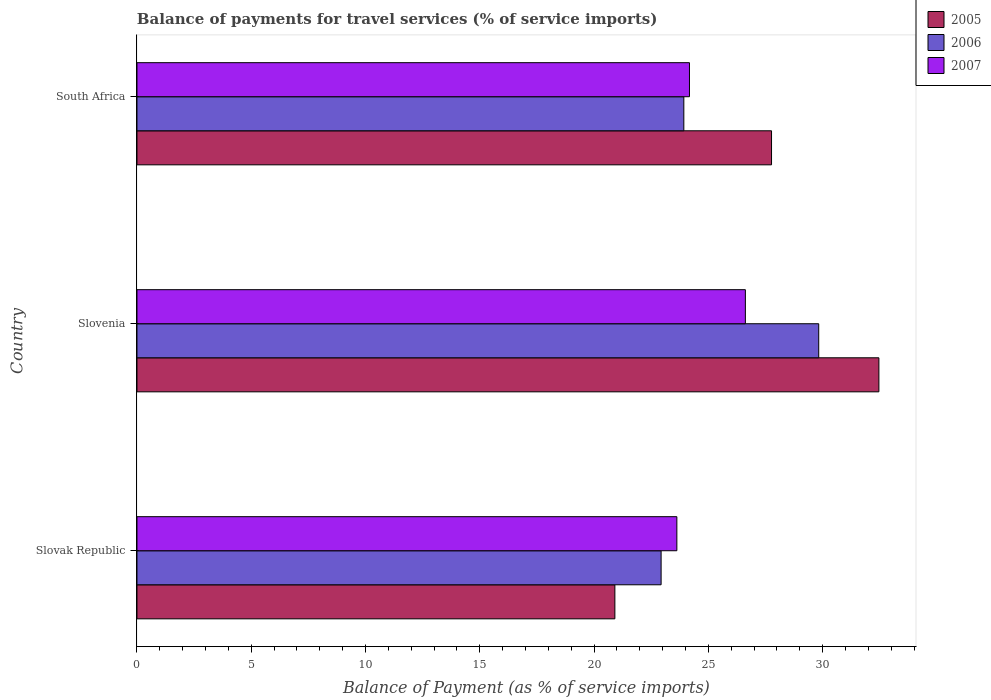How many different coloured bars are there?
Make the answer very short. 3. How many groups of bars are there?
Offer a terse response. 3. Are the number of bars per tick equal to the number of legend labels?
Offer a terse response. Yes. Are the number of bars on each tick of the Y-axis equal?
Your response must be concise. Yes. How many bars are there on the 1st tick from the bottom?
Provide a succinct answer. 3. What is the label of the 1st group of bars from the top?
Give a very brief answer. South Africa. What is the balance of payments for travel services in 2005 in Slovenia?
Offer a terse response. 32.46. Across all countries, what is the maximum balance of payments for travel services in 2006?
Offer a very short reply. 29.83. Across all countries, what is the minimum balance of payments for travel services in 2006?
Make the answer very short. 22.93. In which country was the balance of payments for travel services in 2005 maximum?
Give a very brief answer. Slovenia. In which country was the balance of payments for travel services in 2007 minimum?
Offer a terse response. Slovak Republic. What is the total balance of payments for travel services in 2007 in the graph?
Give a very brief answer. 74.41. What is the difference between the balance of payments for travel services in 2006 in Slovenia and that in South Africa?
Provide a succinct answer. 5.9. What is the difference between the balance of payments for travel services in 2006 in Slovak Republic and the balance of payments for travel services in 2007 in South Africa?
Provide a short and direct response. -1.24. What is the average balance of payments for travel services in 2006 per country?
Make the answer very short. 25.56. What is the difference between the balance of payments for travel services in 2007 and balance of payments for travel services in 2005 in South Africa?
Your answer should be very brief. -3.59. In how many countries, is the balance of payments for travel services in 2005 greater than 33 %?
Your answer should be compact. 0. What is the ratio of the balance of payments for travel services in 2005 in Slovak Republic to that in South Africa?
Your answer should be compact. 0.75. What is the difference between the highest and the second highest balance of payments for travel services in 2006?
Your response must be concise. 5.9. What is the difference between the highest and the lowest balance of payments for travel services in 2005?
Make the answer very short. 11.55. In how many countries, is the balance of payments for travel services in 2007 greater than the average balance of payments for travel services in 2007 taken over all countries?
Offer a very short reply. 1. Is the sum of the balance of payments for travel services in 2006 in Slovak Republic and South Africa greater than the maximum balance of payments for travel services in 2005 across all countries?
Give a very brief answer. Yes. What does the 3rd bar from the bottom in Slovak Republic represents?
Provide a succinct answer. 2007. Is it the case that in every country, the sum of the balance of payments for travel services in 2005 and balance of payments for travel services in 2006 is greater than the balance of payments for travel services in 2007?
Your answer should be compact. Yes. How many bars are there?
Give a very brief answer. 9. What is the difference between two consecutive major ticks on the X-axis?
Offer a very short reply. 5. Are the values on the major ticks of X-axis written in scientific E-notation?
Your response must be concise. No. Does the graph contain grids?
Give a very brief answer. No. Where does the legend appear in the graph?
Offer a terse response. Top right. How many legend labels are there?
Your answer should be very brief. 3. How are the legend labels stacked?
Give a very brief answer. Vertical. What is the title of the graph?
Give a very brief answer. Balance of payments for travel services (% of service imports). Does "1977" appear as one of the legend labels in the graph?
Offer a very short reply. No. What is the label or title of the X-axis?
Ensure brevity in your answer.  Balance of Payment (as % of service imports). What is the label or title of the Y-axis?
Provide a succinct answer. Country. What is the Balance of Payment (as % of service imports) of 2005 in Slovak Republic?
Ensure brevity in your answer.  20.91. What is the Balance of Payment (as % of service imports) of 2006 in Slovak Republic?
Ensure brevity in your answer.  22.93. What is the Balance of Payment (as % of service imports) in 2007 in Slovak Republic?
Your answer should be very brief. 23.62. What is the Balance of Payment (as % of service imports) of 2005 in Slovenia?
Give a very brief answer. 32.46. What is the Balance of Payment (as % of service imports) of 2006 in Slovenia?
Provide a short and direct response. 29.83. What is the Balance of Payment (as % of service imports) in 2007 in Slovenia?
Offer a very short reply. 26.62. What is the Balance of Payment (as % of service imports) in 2005 in South Africa?
Make the answer very short. 27.76. What is the Balance of Payment (as % of service imports) in 2006 in South Africa?
Keep it short and to the point. 23.93. What is the Balance of Payment (as % of service imports) in 2007 in South Africa?
Ensure brevity in your answer.  24.17. Across all countries, what is the maximum Balance of Payment (as % of service imports) in 2005?
Offer a very short reply. 32.46. Across all countries, what is the maximum Balance of Payment (as % of service imports) in 2006?
Make the answer very short. 29.83. Across all countries, what is the maximum Balance of Payment (as % of service imports) in 2007?
Offer a terse response. 26.62. Across all countries, what is the minimum Balance of Payment (as % of service imports) in 2005?
Offer a terse response. 20.91. Across all countries, what is the minimum Balance of Payment (as % of service imports) of 2006?
Offer a terse response. 22.93. Across all countries, what is the minimum Balance of Payment (as % of service imports) in 2007?
Ensure brevity in your answer.  23.62. What is the total Balance of Payment (as % of service imports) of 2005 in the graph?
Your response must be concise. 81.13. What is the total Balance of Payment (as % of service imports) in 2006 in the graph?
Offer a very short reply. 76.69. What is the total Balance of Payment (as % of service imports) of 2007 in the graph?
Provide a succinct answer. 74.41. What is the difference between the Balance of Payment (as % of service imports) of 2005 in Slovak Republic and that in Slovenia?
Offer a terse response. -11.55. What is the difference between the Balance of Payment (as % of service imports) in 2006 in Slovak Republic and that in Slovenia?
Offer a terse response. -6.9. What is the difference between the Balance of Payment (as % of service imports) of 2007 in Slovak Republic and that in Slovenia?
Keep it short and to the point. -3. What is the difference between the Balance of Payment (as % of service imports) in 2005 in Slovak Republic and that in South Africa?
Offer a terse response. -6.85. What is the difference between the Balance of Payment (as % of service imports) of 2006 in Slovak Republic and that in South Africa?
Your answer should be very brief. -0.99. What is the difference between the Balance of Payment (as % of service imports) of 2007 in Slovak Republic and that in South Africa?
Provide a short and direct response. -0.55. What is the difference between the Balance of Payment (as % of service imports) in 2005 in Slovenia and that in South Africa?
Ensure brevity in your answer.  4.7. What is the difference between the Balance of Payment (as % of service imports) in 2006 in Slovenia and that in South Africa?
Provide a succinct answer. 5.9. What is the difference between the Balance of Payment (as % of service imports) of 2007 in Slovenia and that in South Africa?
Give a very brief answer. 2.45. What is the difference between the Balance of Payment (as % of service imports) in 2005 in Slovak Republic and the Balance of Payment (as % of service imports) in 2006 in Slovenia?
Keep it short and to the point. -8.92. What is the difference between the Balance of Payment (as % of service imports) of 2005 in Slovak Republic and the Balance of Payment (as % of service imports) of 2007 in Slovenia?
Your answer should be compact. -5.71. What is the difference between the Balance of Payment (as % of service imports) in 2006 in Slovak Republic and the Balance of Payment (as % of service imports) in 2007 in Slovenia?
Provide a succinct answer. -3.69. What is the difference between the Balance of Payment (as % of service imports) of 2005 in Slovak Republic and the Balance of Payment (as % of service imports) of 2006 in South Africa?
Offer a very short reply. -3.02. What is the difference between the Balance of Payment (as % of service imports) of 2005 in Slovak Republic and the Balance of Payment (as % of service imports) of 2007 in South Africa?
Ensure brevity in your answer.  -3.26. What is the difference between the Balance of Payment (as % of service imports) of 2006 in Slovak Republic and the Balance of Payment (as % of service imports) of 2007 in South Africa?
Your answer should be very brief. -1.24. What is the difference between the Balance of Payment (as % of service imports) of 2005 in Slovenia and the Balance of Payment (as % of service imports) of 2006 in South Africa?
Give a very brief answer. 8.53. What is the difference between the Balance of Payment (as % of service imports) in 2005 in Slovenia and the Balance of Payment (as % of service imports) in 2007 in South Africa?
Provide a short and direct response. 8.29. What is the difference between the Balance of Payment (as % of service imports) of 2006 in Slovenia and the Balance of Payment (as % of service imports) of 2007 in South Africa?
Provide a succinct answer. 5.66. What is the average Balance of Payment (as % of service imports) in 2005 per country?
Offer a terse response. 27.04. What is the average Balance of Payment (as % of service imports) of 2006 per country?
Provide a short and direct response. 25.56. What is the average Balance of Payment (as % of service imports) of 2007 per country?
Offer a very short reply. 24.8. What is the difference between the Balance of Payment (as % of service imports) of 2005 and Balance of Payment (as % of service imports) of 2006 in Slovak Republic?
Provide a short and direct response. -2.02. What is the difference between the Balance of Payment (as % of service imports) in 2005 and Balance of Payment (as % of service imports) in 2007 in Slovak Republic?
Keep it short and to the point. -2.71. What is the difference between the Balance of Payment (as % of service imports) of 2006 and Balance of Payment (as % of service imports) of 2007 in Slovak Republic?
Your response must be concise. -0.69. What is the difference between the Balance of Payment (as % of service imports) of 2005 and Balance of Payment (as % of service imports) of 2006 in Slovenia?
Keep it short and to the point. 2.63. What is the difference between the Balance of Payment (as % of service imports) in 2005 and Balance of Payment (as % of service imports) in 2007 in Slovenia?
Your answer should be compact. 5.84. What is the difference between the Balance of Payment (as % of service imports) in 2006 and Balance of Payment (as % of service imports) in 2007 in Slovenia?
Your answer should be compact. 3.21. What is the difference between the Balance of Payment (as % of service imports) of 2005 and Balance of Payment (as % of service imports) of 2006 in South Africa?
Offer a very short reply. 3.84. What is the difference between the Balance of Payment (as % of service imports) of 2005 and Balance of Payment (as % of service imports) of 2007 in South Africa?
Offer a terse response. 3.59. What is the difference between the Balance of Payment (as % of service imports) of 2006 and Balance of Payment (as % of service imports) of 2007 in South Africa?
Give a very brief answer. -0.25. What is the ratio of the Balance of Payment (as % of service imports) in 2005 in Slovak Republic to that in Slovenia?
Ensure brevity in your answer.  0.64. What is the ratio of the Balance of Payment (as % of service imports) in 2006 in Slovak Republic to that in Slovenia?
Provide a succinct answer. 0.77. What is the ratio of the Balance of Payment (as % of service imports) of 2007 in Slovak Republic to that in Slovenia?
Ensure brevity in your answer.  0.89. What is the ratio of the Balance of Payment (as % of service imports) of 2005 in Slovak Republic to that in South Africa?
Provide a succinct answer. 0.75. What is the ratio of the Balance of Payment (as % of service imports) of 2006 in Slovak Republic to that in South Africa?
Your answer should be very brief. 0.96. What is the ratio of the Balance of Payment (as % of service imports) in 2007 in Slovak Republic to that in South Africa?
Keep it short and to the point. 0.98. What is the ratio of the Balance of Payment (as % of service imports) in 2005 in Slovenia to that in South Africa?
Provide a short and direct response. 1.17. What is the ratio of the Balance of Payment (as % of service imports) in 2006 in Slovenia to that in South Africa?
Give a very brief answer. 1.25. What is the ratio of the Balance of Payment (as % of service imports) in 2007 in Slovenia to that in South Africa?
Your answer should be very brief. 1.1. What is the difference between the highest and the second highest Balance of Payment (as % of service imports) of 2005?
Make the answer very short. 4.7. What is the difference between the highest and the second highest Balance of Payment (as % of service imports) in 2006?
Make the answer very short. 5.9. What is the difference between the highest and the second highest Balance of Payment (as % of service imports) of 2007?
Make the answer very short. 2.45. What is the difference between the highest and the lowest Balance of Payment (as % of service imports) of 2005?
Give a very brief answer. 11.55. What is the difference between the highest and the lowest Balance of Payment (as % of service imports) in 2006?
Your response must be concise. 6.9. What is the difference between the highest and the lowest Balance of Payment (as % of service imports) in 2007?
Provide a succinct answer. 3. 